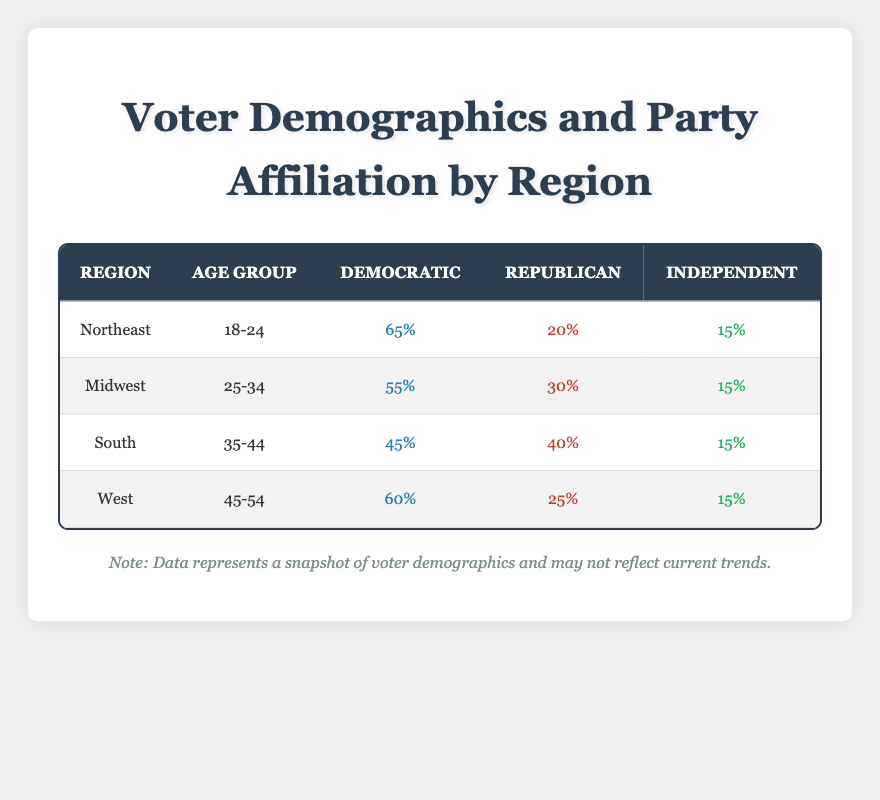What percentage of voters aged 18-24 in the Northeast identify as Democratic? In the row for the Northeast and age group 18-24, the table shows that 65% identify as Democratic.
Answer: 65% Which age group in the South has the highest percentage of Republican voters? The table indicates the South has 40% Republican voters in the 35-44 age group, which is greater than any other age group presented for the South.
Answer: 35-44 What is the total percentage of Independent voters across all regions for the 25-34 age group? The table shows 15% Independent voters in both the Midwest (25-34 age group), so adding these gives 15%. There are no Independent voters mentioned for the 25-34 age group in other regions, resulting in a total of 15%.
Answer: 15% Is there any age group where the Republican percentage is higher than the Democratic percentage in the West? In the West, for the age group 45-54, Democrats have 60% and Republicans have 25%. Since Republicans do not exceed Democrats in this case, the answer is no.
Answer: No What is the difference in percentage points between Democratic and Republican voters in the Midwest for the 25-34 age group? In the Midwest for the 25-34 age group, Democrats have 55% and Republicans have 30%. The difference is calculated as 55% - 30% = 25 percentage points.
Answer: 25 What is the average percentage of Independent voters across all regions and age groups? Adding the percentages of Independent voters: 15% (Northeast) + 15% (Midwest) + 15% (South) + 15% (West) = 60%. Since there are 4 data points, the average is calculated as 60% / 4 = 15%.
Answer: 15 Which region has the highest percentage of Democratic voters aged 45-54? The table shows that the West has 60% Democratic voters in the 45-54 age group, which is higher compared to the other regions with their respective age group percentages.
Answer: West Is the percentage of Democratic voters in the 18-24 age group in the Northeast greater than that of Independent voters in the same age group? The Northeast has 65% Democratic voters in the 18-24 age group and 15% Independent voters in the same age group. 65% is greater than 15%, confirming the statement is true.
Answer: Yes 